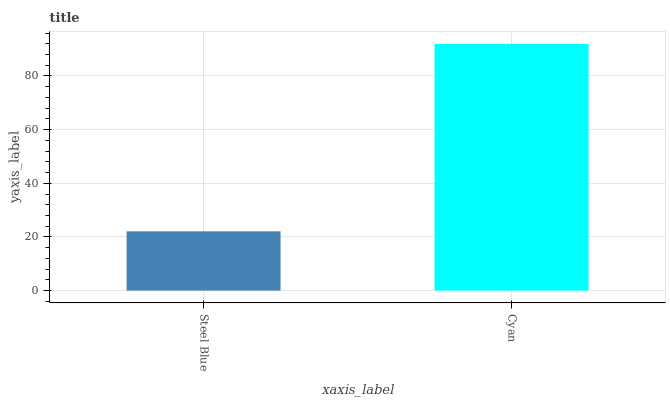Is Cyan the minimum?
Answer yes or no. No. Is Cyan greater than Steel Blue?
Answer yes or no. Yes. Is Steel Blue less than Cyan?
Answer yes or no. Yes. Is Steel Blue greater than Cyan?
Answer yes or no. No. Is Cyan less than Steel Blue?
Answer yes or no. No. Is Cyan the high median?
Answer yes or no. Yes. Is Steel Blue the low median?
Answer yes or no. Yes. Is Steel Blue the high median?
Answer yes or no. No. Is Cyan the low median?
Answer yes or no. No. 